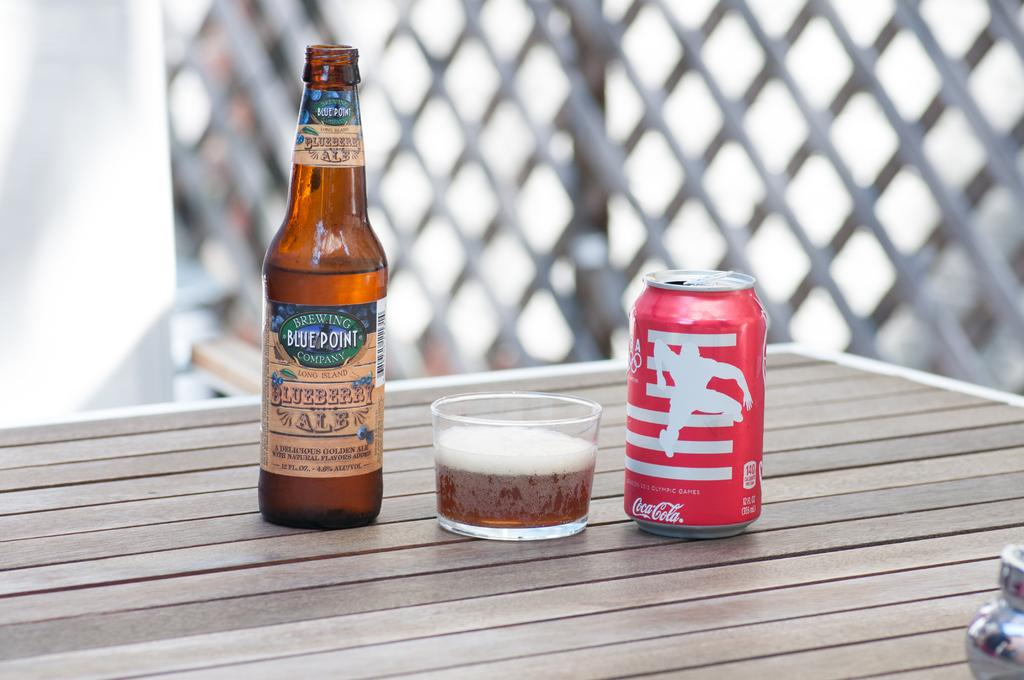<image>
Present a compact description of the photo's key features. A can of Coca Cola stands to the right of a bottle of beer. 